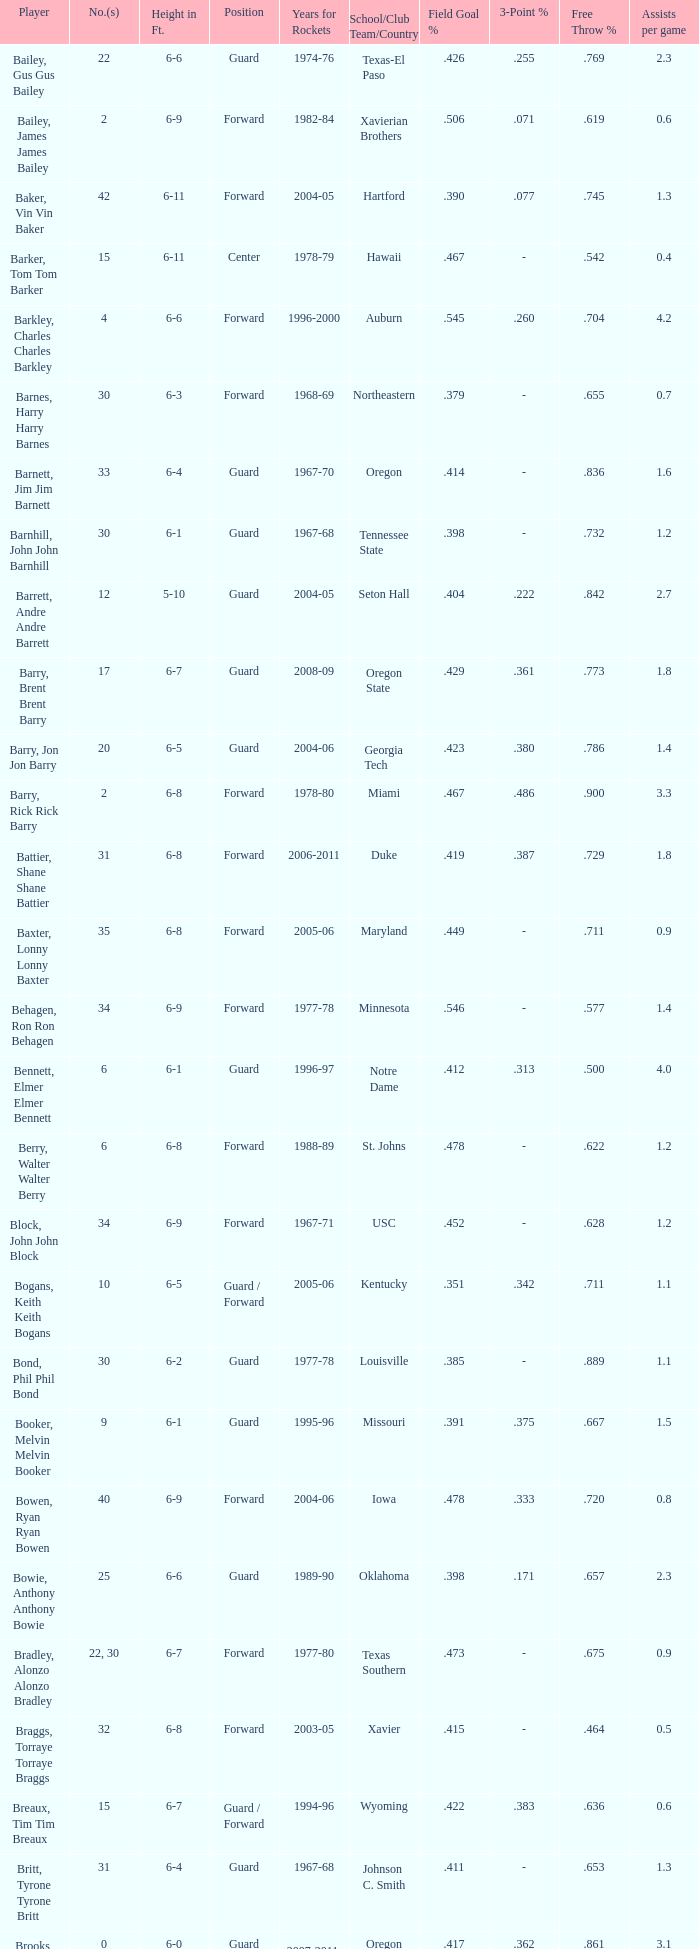What school did the forward whose number is 10 belong to? Arizona. 